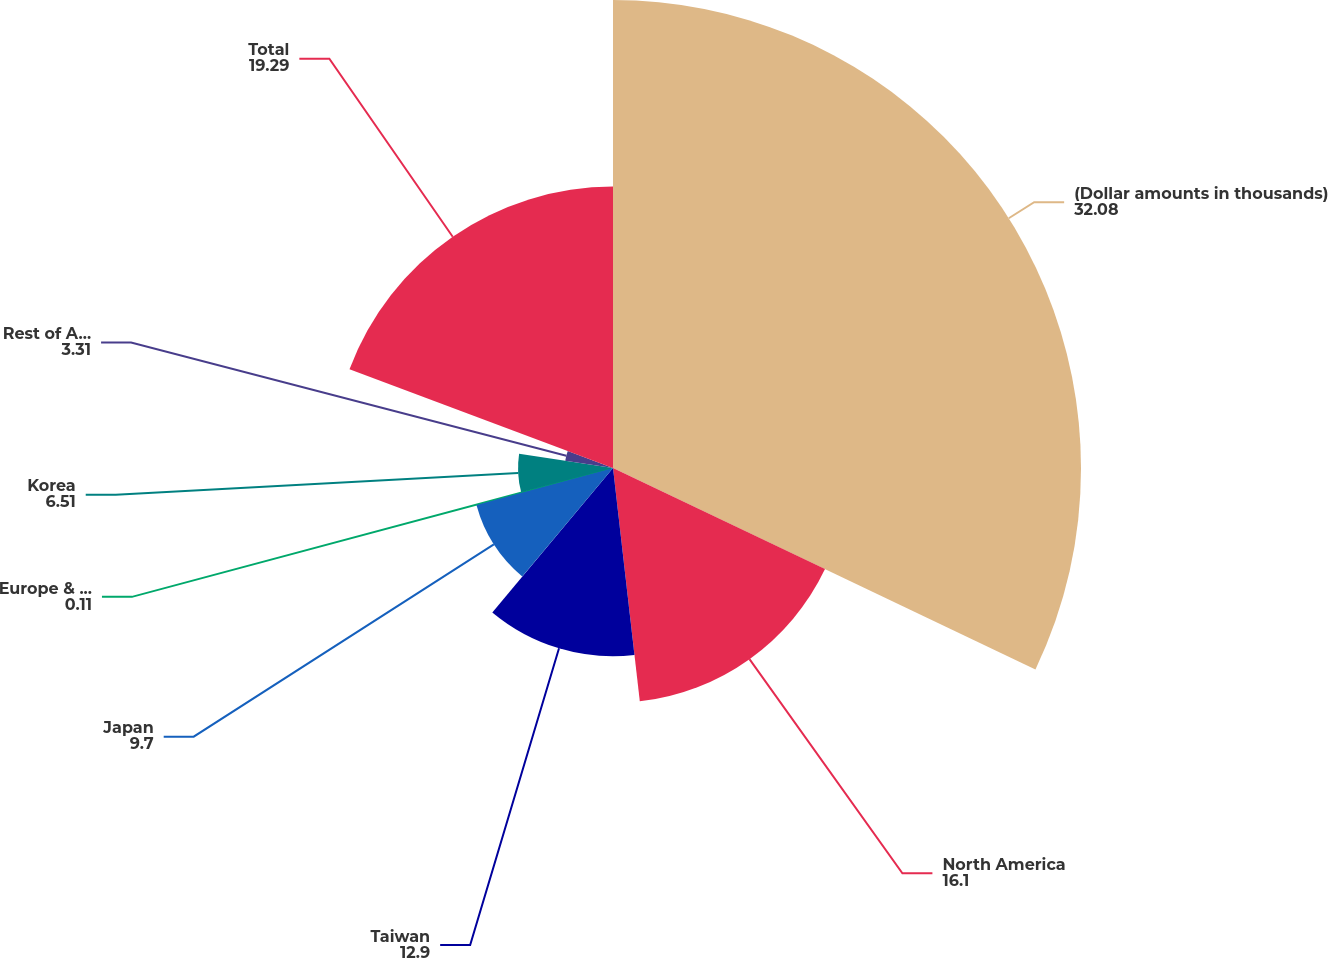Convert chart. <chart><loc_0><loc_0><loc_500><loc_500><pie_chart><fcel>(Dollar amounts in thousands)<fcel>North America<fcel>Taiwan<fcel>Japan<fcel>Europe & Israel<fcel>Korea<fcel>Rest of Asia<fcel>Total<nl><fcel>32.08%<fcel>16.1%<fcel>12.9%<fcel>9.7%<fcel>0.11%<fcel>6.51%<fcel>3.31%<fcel>19.29%<nl></chart> 